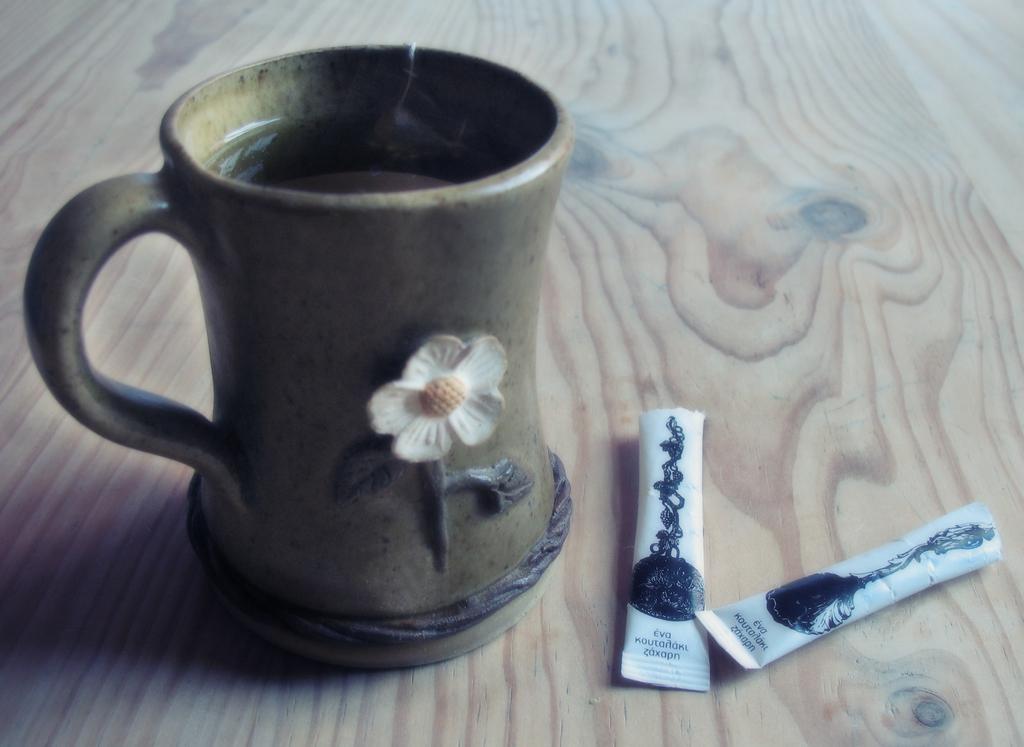Could you give a brief overview of what you see in this image? In this image there is a cup on the wooden surface. There is the drink in the cup. On the cup there is a sculpture of a flower. Beside the cup there are two food packets. There are pictures and text on the food packets. 